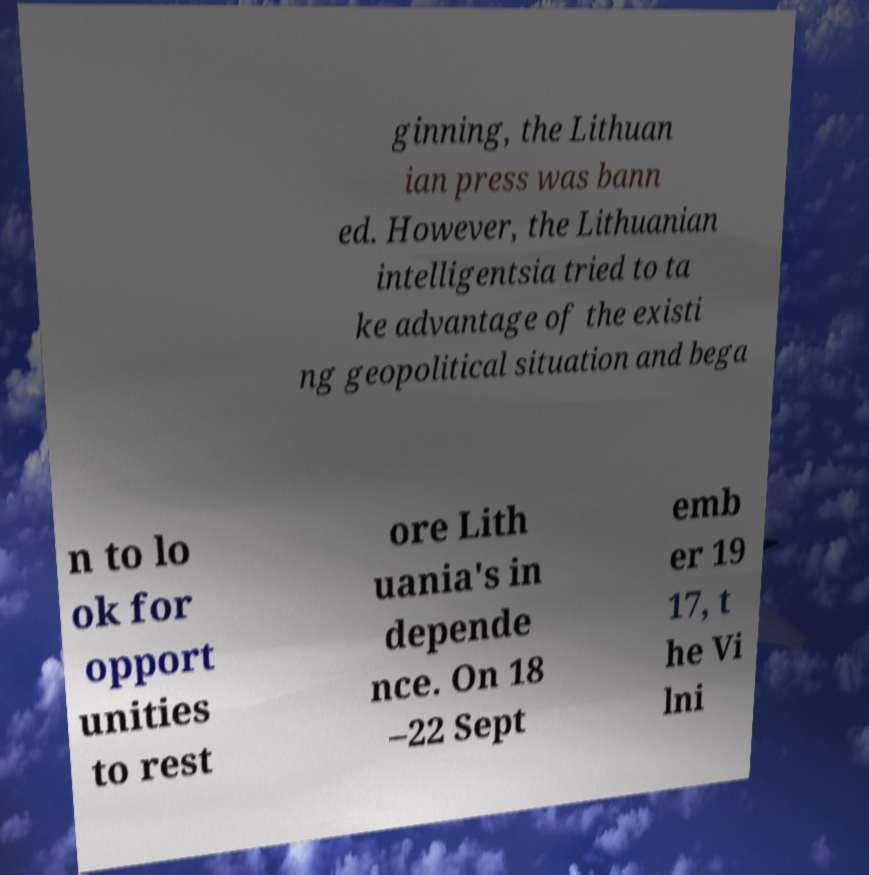Please read and relay the text visible in this image. What does it say? ginning, the Lithuan ian press was bann ed. However, the Lithuanian intelligentsia tried to ta ke advantage of the existi ng geopolitical situation and bega n to lo ok for opport unities to rest ore Lith uania's in depende nce. On 18 –22 Sept emb er 19 17, t he Vi lni 